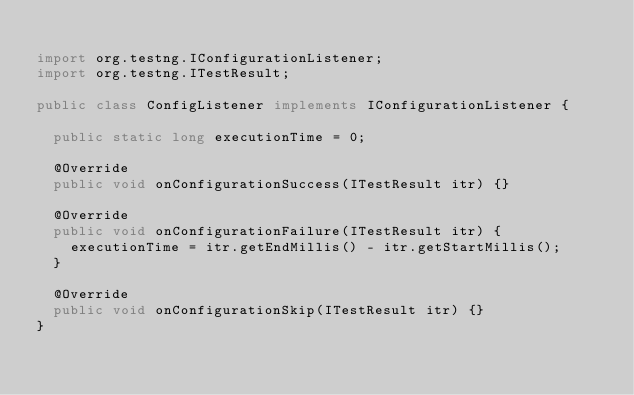<code> <loc_0><loc_0><loc_500><loc_500><_Java_>
import org.testng.IConfigurationListener;
import org.testng.ITestResult;

public class ConfigListener implements IConfigurationListener {

  public static long executionTime = 0;

  @Override
  public void onConfigurationSuccess(ITestResult itr) {}

  @Override
  public void onConfigurationFailure(ITestResult itr) {
    executionTime = itr.getEndMillis() - itr.getStartMillis();
  }

  @Override
  public void onConfigurationSkip(ITestResult itr) {}
}
</code> 